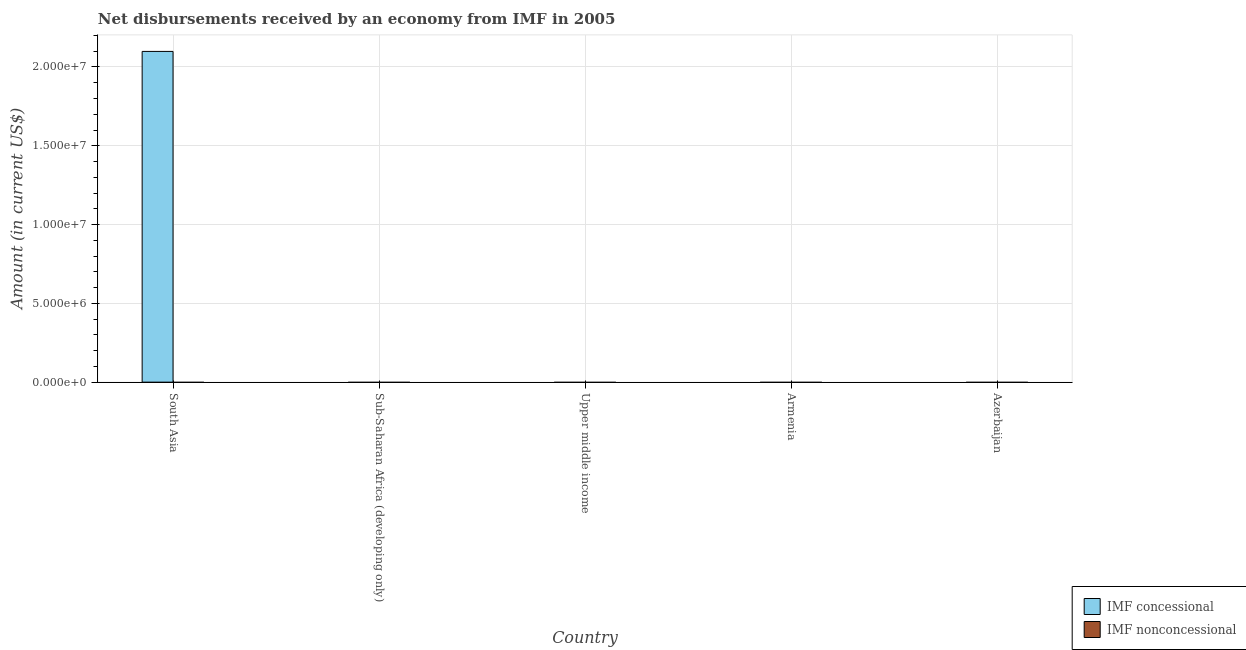How many different coloured bars are there?
Your answer should be very brief. 1. Are the number of bars per tick equal to the number of legend labels?
Keep it short and to the point. No. Are the number of bars on each tick of the X-axis equal?
Offer a very short reply. No. How many bars are there on the 2nd tick from the left?
Offer a terse response. 0. What is the label of the 2nd group of bars from the left?
Provide a short and direct response. Sub-Saharan Africa (developing only). In how many cases, is the number of bars for a given country not equal to the number of legend labels?
Your response must be concise. 5. In which country was the net concessional disbursements from imf maximum?
Provide a succinct answer. South Asia. What is the total net concessional disbursements from imf in the graph?
Make the answer very short. 2.10e+07. What is the average net concessional disbursements from imf per country?
Your answer should be compact. 4.20e+06. In how many countries, is the net concessional disbursements from imf greater than 6000000 US$?
Make the answer very short. 1. What is the difference between the highest and the lowest net concessional disbursements from imf?
Your answer should be very brief. 2.10e+07. In how many countries, is the net concessional disbursements from imf greater than the average net concessional disbursements from imf taken over all countries?
Provide a short and direct response. 1. How many countries are there in the graph?
Provide a succinct answer. 5. What is the difference between two consecutive major ticks on the Y-axis?
Your answer should be compact. 5.00e+06. Are the values on the major ticks of Y-axis written in scientific E-notation?
Offer a terse response. Yes. Does the graph contain any zero values?
Your response must be concise. Yes. How many legend labels are there?
Your answer should be very brief. 2. How are the legend labels stacked?
Your answer should be compact. Vertical. What is the title of the graph?
Your answer should be very brief. Net disbursements received by an economy from IMF in 2005. Does "Highest 20% of population" appear as one of the legend labels in the graph?
Keep it short and to the point. No. What is the Amount (in current US$) of IMF concessional in South Asia?
Keep it short and to the point. 2.10e+07. What is the Amount (in current US$) in IMF nonconcessional in Sub-Saharan Africa (developing only)?
Your response must be concise. 0. What is the Amount (in current US$) in IMF concessional in Upper middle income?
Your answer should be very brief. 0. What is the Amount (in current US$) in IMF nonconcessional in Upper middle income?
Keep it short and to the point. 0. What is the Amount (in current US$) of IMF nonconcessional in Armenia?
Your answer should be very brief. 0. What is the Amount (in current US$) of IMF concessional in Azerbaijan?
Provide a short and direct response. 0. Across all countries, what is the maximum Amount (in current US$) of IMF concessional?
Your answer should be very brief. 2.10e+07. Across all countries, what is the minimum Amount (in current US$) of IMF concessional?
Offer a very short reply. 0. What is the total Amount (in current US$) of IMF concessional in the graph?
Give a very brief answer. 2.10e+07. What is the total Amount (in current US$) of IMF nonconcessional in the graph?
Your answer should be compact. 0. What is the average Amount (in current US$) in IMF concessional per country?
Ensure brevity in your answer.  4.20e+06. What is the difference between the highest and the lowest Amount (in current US$) in IMF concessional?
Your answer should be very brief. 2.10e+07. 